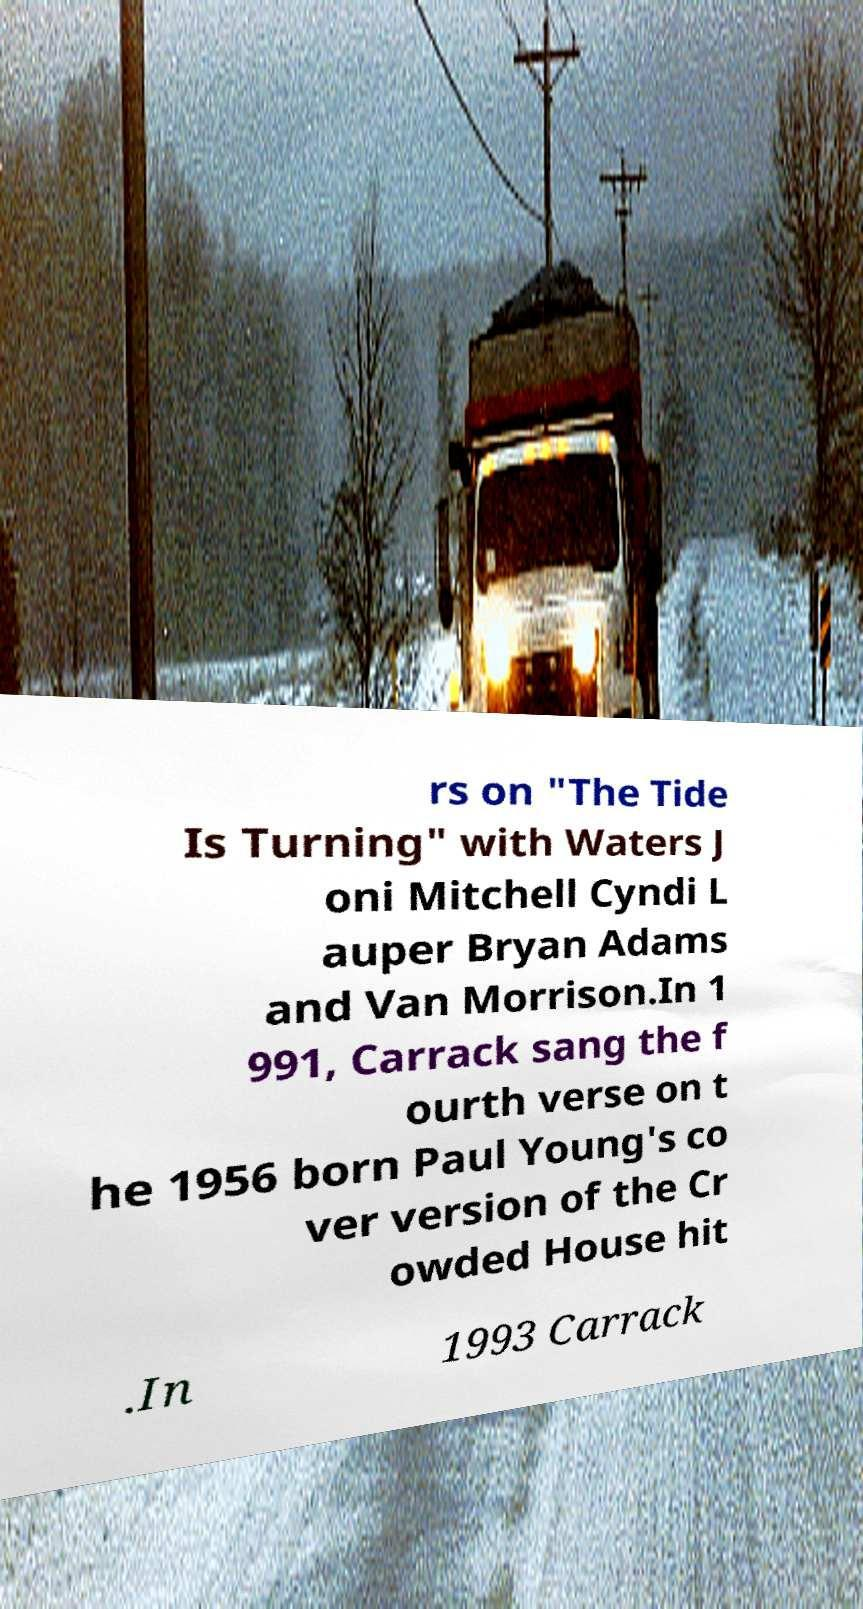What messages or text are displayed in this image? I need them in a readable, typed format. rs on "The Tide Is Turning" with Waters J oni Mitchell Cyndi L auper Bryan Adams and Van Morrison.In 1 991, Carrack sang the f ourth verse on t he 1956 born Paul Young's co ver version of the Cr owded House hit .In 1993 Carrack 